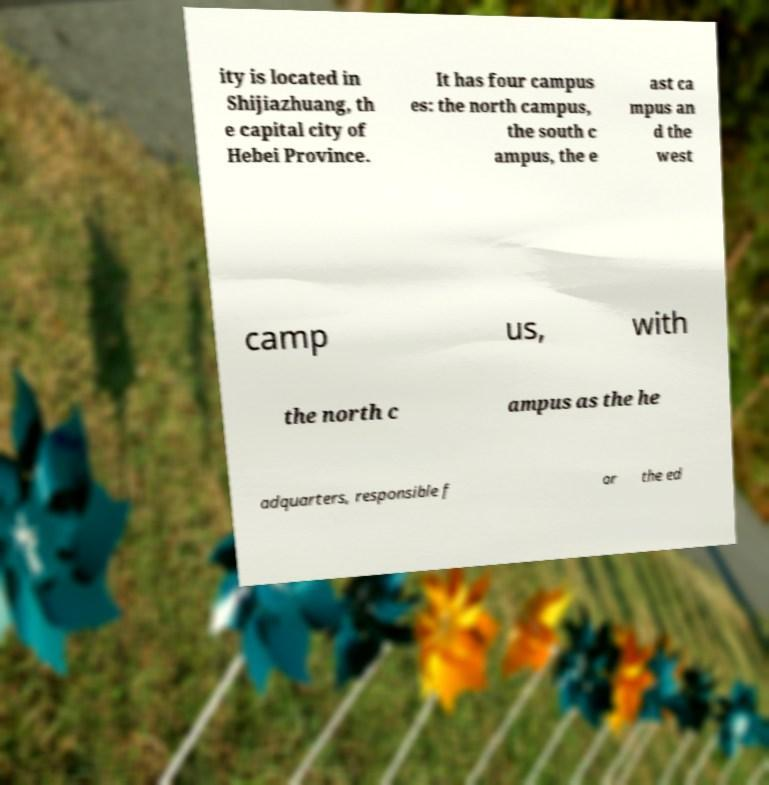Please read and relay the text visible in this image. What does it say? ity is located in Shijiazhuang, th e capital city of Hebei Province. It has four campus es: the north campus, the south c ampus, the e ast ca mpus an d the west camp us, with the north c ampus as the he adquarters, responsible f or the ed 